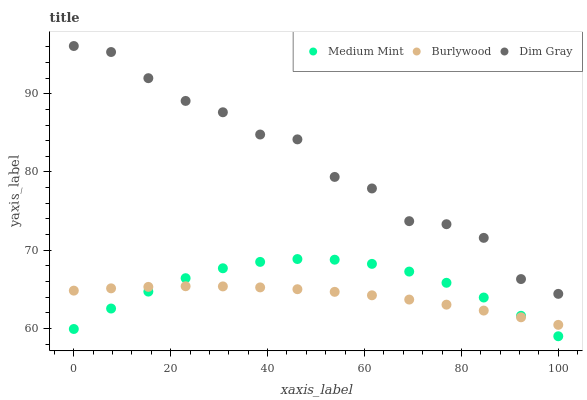Does Burlywood have the minimum area under the curve?
Answer yes or no. Yes. Does Dim Gray have the maximum area under the curve?
Answer yes or no. Yes. Does Dim Gray have the minimum area under the curve?
Answer yes or no. No. Does Burlywood have the maximum area under the curve?
Answer yes or no. No. Is Burlywood the smoothest?
Answer yes or no. Yes. Is Dim Gray the roughest?
Answer yes or no. Yes. Is Dim Gray the smoothest?
Answer yes or no. No. Is Burlywood the roughest?
Answer yes or no. No. Does Medium Mint have the lowest value?
Answer yes or no. Yes. Does Burlywood have the lowest value?
Answer yes or no. No. Does Dim Gray have the highest value?
Answer yes or no. Yes. Does Burlywood have the highest value?
Answer yes or no. No. Is Burlywood less than Dim Gray?
Answer yes or no. Yes. Is Dim Gray greater than Medium Mint?
Answer yes or no. Yes. Does Burlywood intersect Medium Mint?
Answer yes or no. Yes. Is Burlywood less than Medium Mint?
Answer yes or no. No. Is Burlywood greater than Medium Mint?
Answer yes or no. No. Does Burlywood intersect Dim Gray?
Answer yes or no. No. 